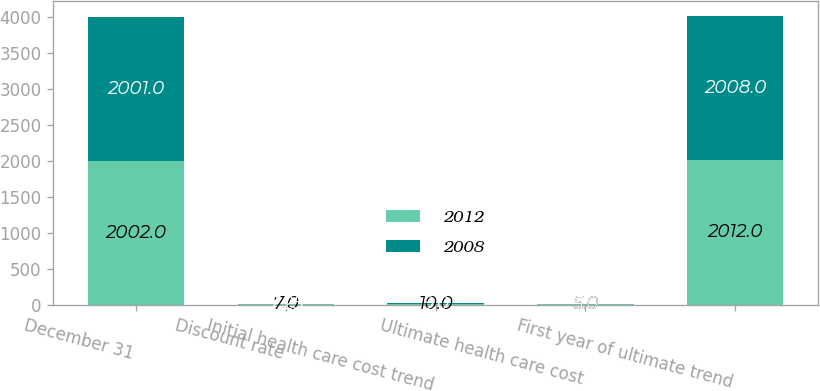Convert chart to OTSL. <chart><loc_0><loc_0><loc_500><loc_500><stacked_bar_chart><ecel><fcel>December 31<fcel>Discount rate<fcel>Initial health care cost trend<fcel>Ultimate health care cost<fcel>First year of ultimate trend<nl><fcel>2012<fcel>2002<fcel>7<fcel>10<fcel>5<fcel>2012<nl><fcel>2008<fcel>2001<fcel>7.25<fcel>9<fcel>5<fcel>2008<nl></chart> 